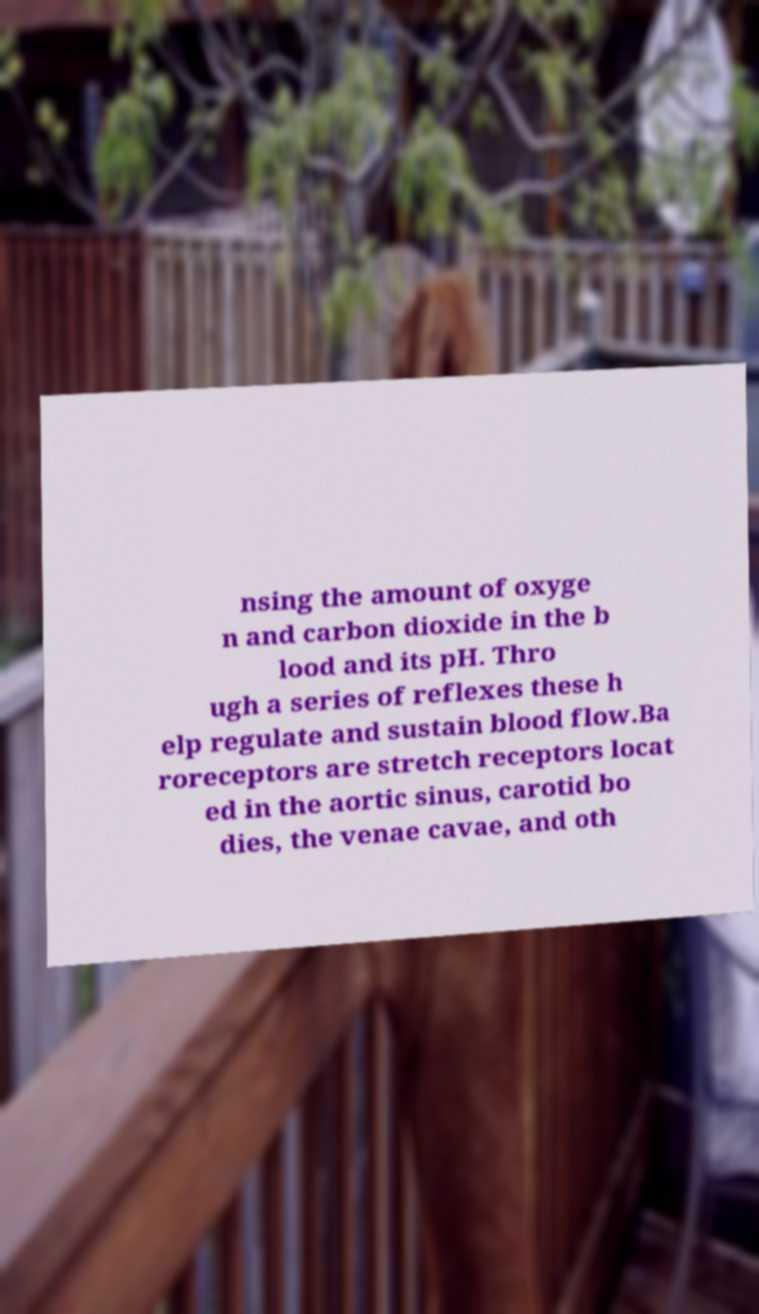Could you assist in decoding the text presented in this image and type it out clearly? nsing the amount of oxyge n and carbon dioxide in the b lood and its pH. Thro ugh a series of reflexes these h elp regulate and sustain blood flow.Ba roreceptors are stretch receptors locat ed in the aortic sinus, carotid bo dies, the venae cavae, and oth 